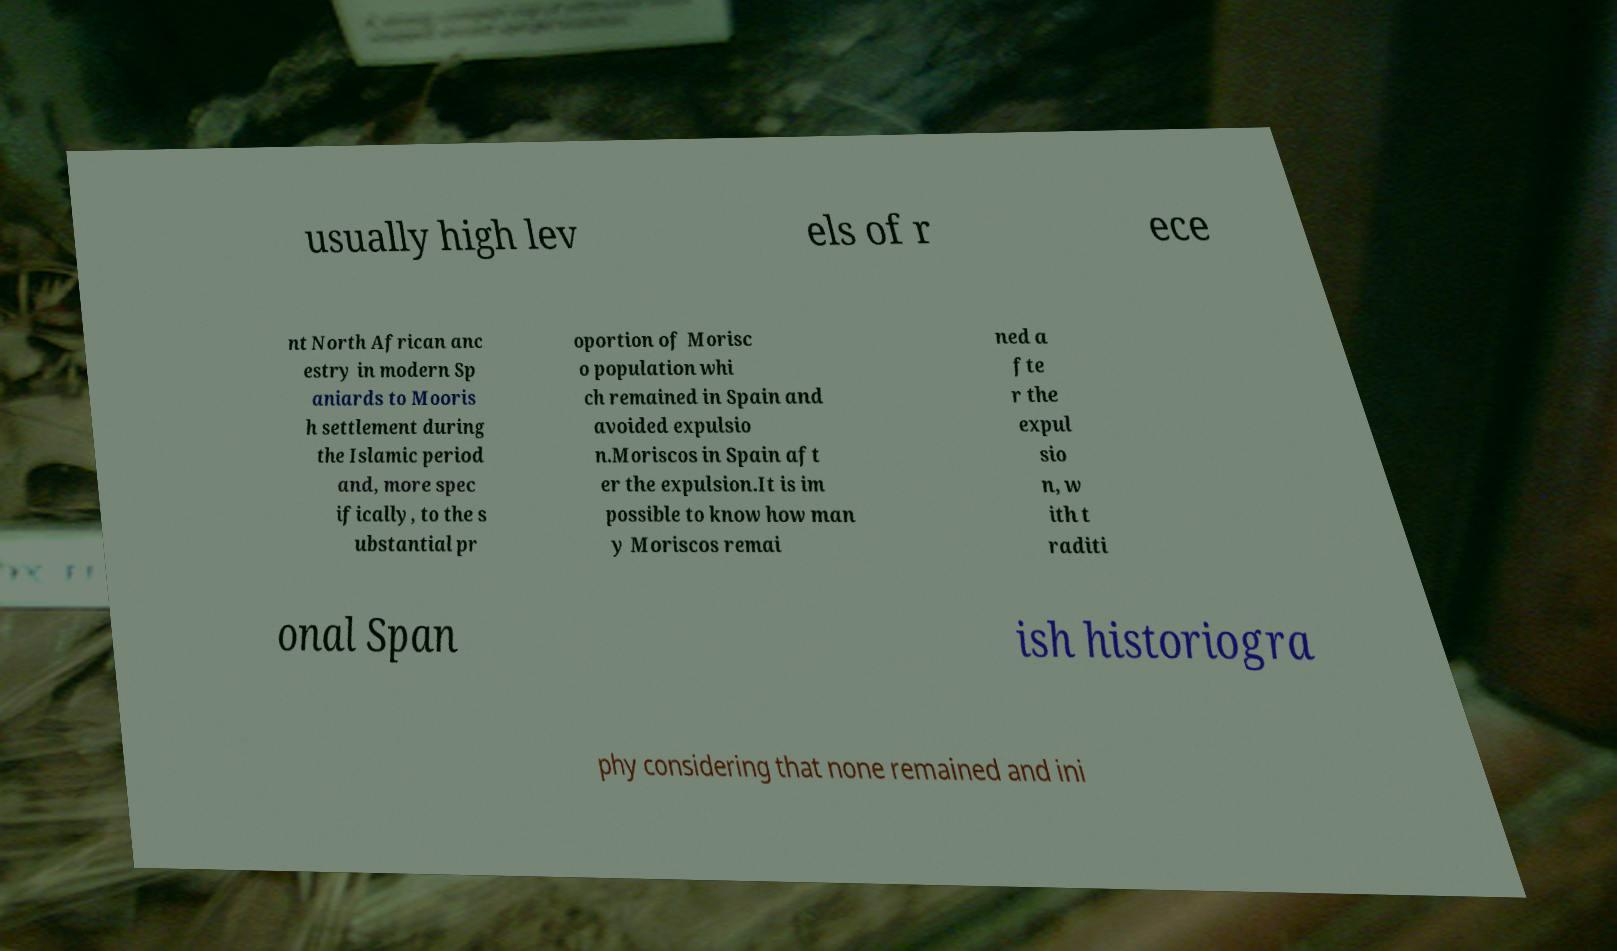Can you read and provide the text displayed in the image?This photo seems to have some interesting text. Can you extract and type it out for me? usually high lev els of r ece nt North African anc estry in modern Sp aniards to Mooris h settlement during the Islamic period and, more spec ifically, to the s ubstantial pr oportion of Morisc o population whi ch remained in Spain and avoided expulsio n.Moriscos in Spain aft er the expulsion.It is im possible to know how man y Moriscos remai ned a fte r the expul sio n, w ith t raditi onal Span ish historiogra phy considering that none remained and ini 